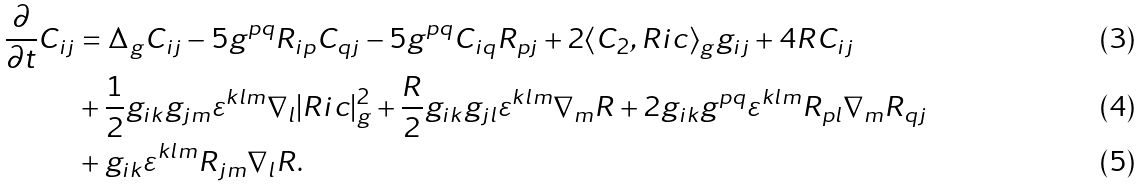Convert formula to latex. <formula><loc_0><loc_0><loc_500><loc_500>\frac { \partial } { \partial t } C _ { i j } & = \Delta _ { g } C _ { i j } - 5 g ^ { p q } R _ { i p } C _ { q j } - 5 g ^ { p q } C _ { i q } R _ { p j } + 2 \langle C _ { 2 } , R i c \rangle _ { g } g _ { i j } + 4 R C _ { i j } \\ & + \frac { 1 } { 2 } g _ { i k } g _ { j m } \varepsilon ^ { k l m } \nabla _ { l } | R i c | _ { g } ^ { 2 } + \frac { R } { 2 } g _ { i k } g _ { j l } \varepsilon ^ { k l m } \nabla _ { m } R + 2 g _ { i k } g ^ { p q } \varepsilon ^ { k l m } R _ { p l } \nabla _ { m } R _ { q j } \\ & + g _ { i k } \varepsilon ^ { k l m } R _ { j m } \nabla _ { l } R .</formula> 